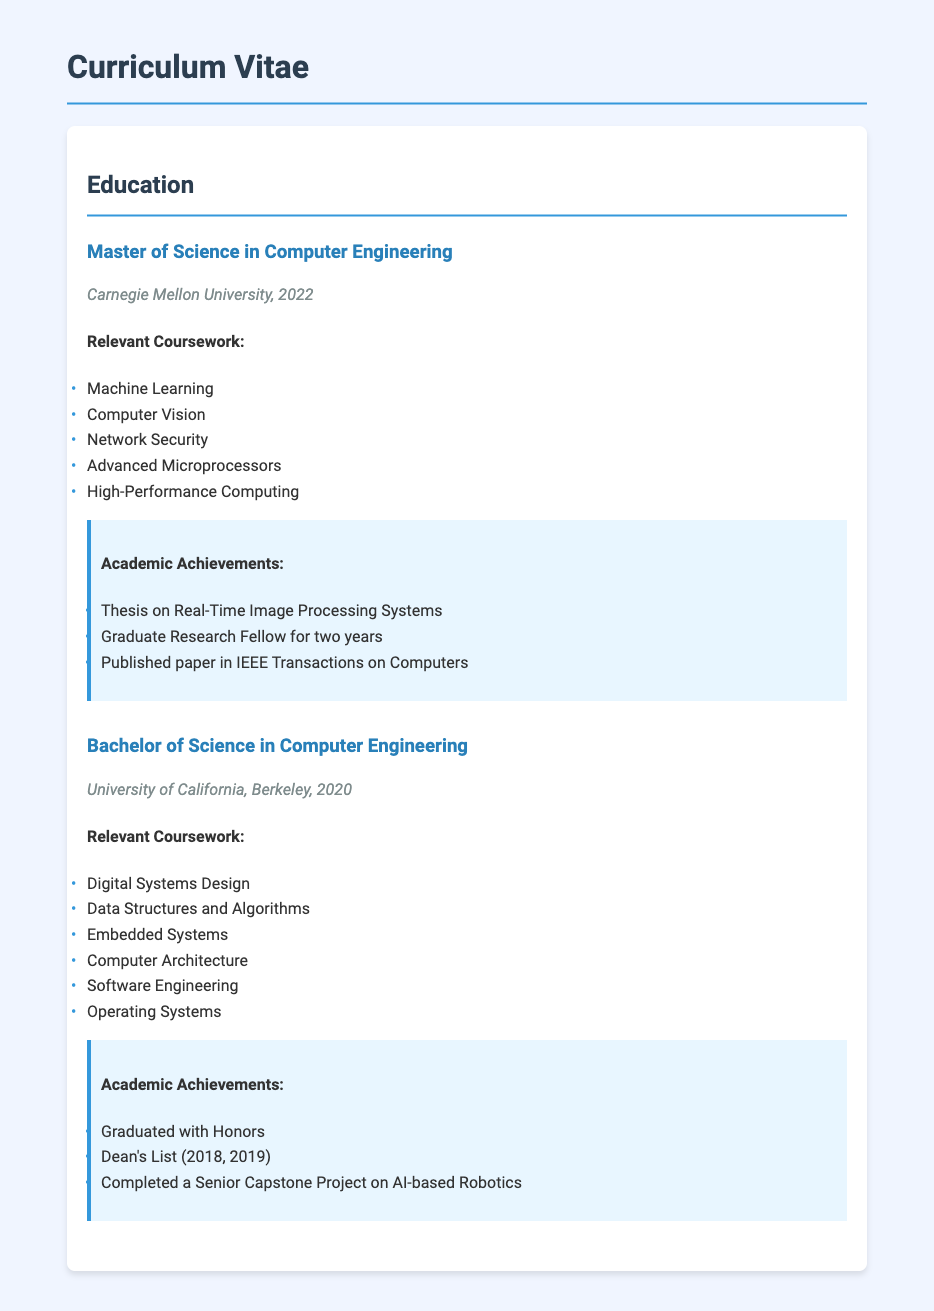What degree was obtained from Carnegie Mellon University? The document states that a Master of Science in Computer Engineering was obtained from Carnegie Mellon University.
Answer: Master of Science in Computer Engineering What is one relevant coursework topic from the Bachelor's degree? The document provides a list of relevant coursework for the Bachelor of Science in Computer Engineering, which includes topics like Digital Systems Design.
Answer: Digital Systems Design What year was the Bachelor's degree completed? According to the document, the Bachelor of Science in Computer Engineering was completed in 2020.
Answer: 2020 Which institution awarded the Master's degree? The document indicates that the Master's degree was awarded by Carnegie Mellon University.
Answer: Carnegie Mellon University What achievement is related to the Graduate Research Fellowship? The document lists that the person was a Graduate Research Fellow for two years as part of their academic achievements in the Master's program.
Answer: Graduate Research Fellow for two years How many courses are listed under the Master's degree? The document enumerates five relevant coursework topics under the Master's degree, indicating the number of courses listed.
Answer: Five What honors were received during the Bachelor's degree? The document states that the person graduated with honors during their Bachelor of Science in Computer Engineering.
Answer: Graduated with Honors Which paper was published during the Master's degree? The document mentions that a paper was published in IEEE Transactions on Computers as part of the academic achievements for the Master's degree.
Answer: Published paper in IEEE Transactions on Computers What project was completed during the Bachelor's program? The document reveals that a Senior Capstone Project on AI-based Robotics was completed during the Bachelor's program.
Answer: Senior Capstone Project on AI-based Robotics 